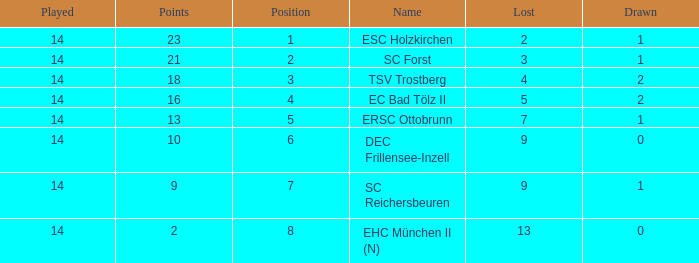Which Lost is the lowest one that has a Name of esc holzkirchen, and Played smaller than 14? None. 